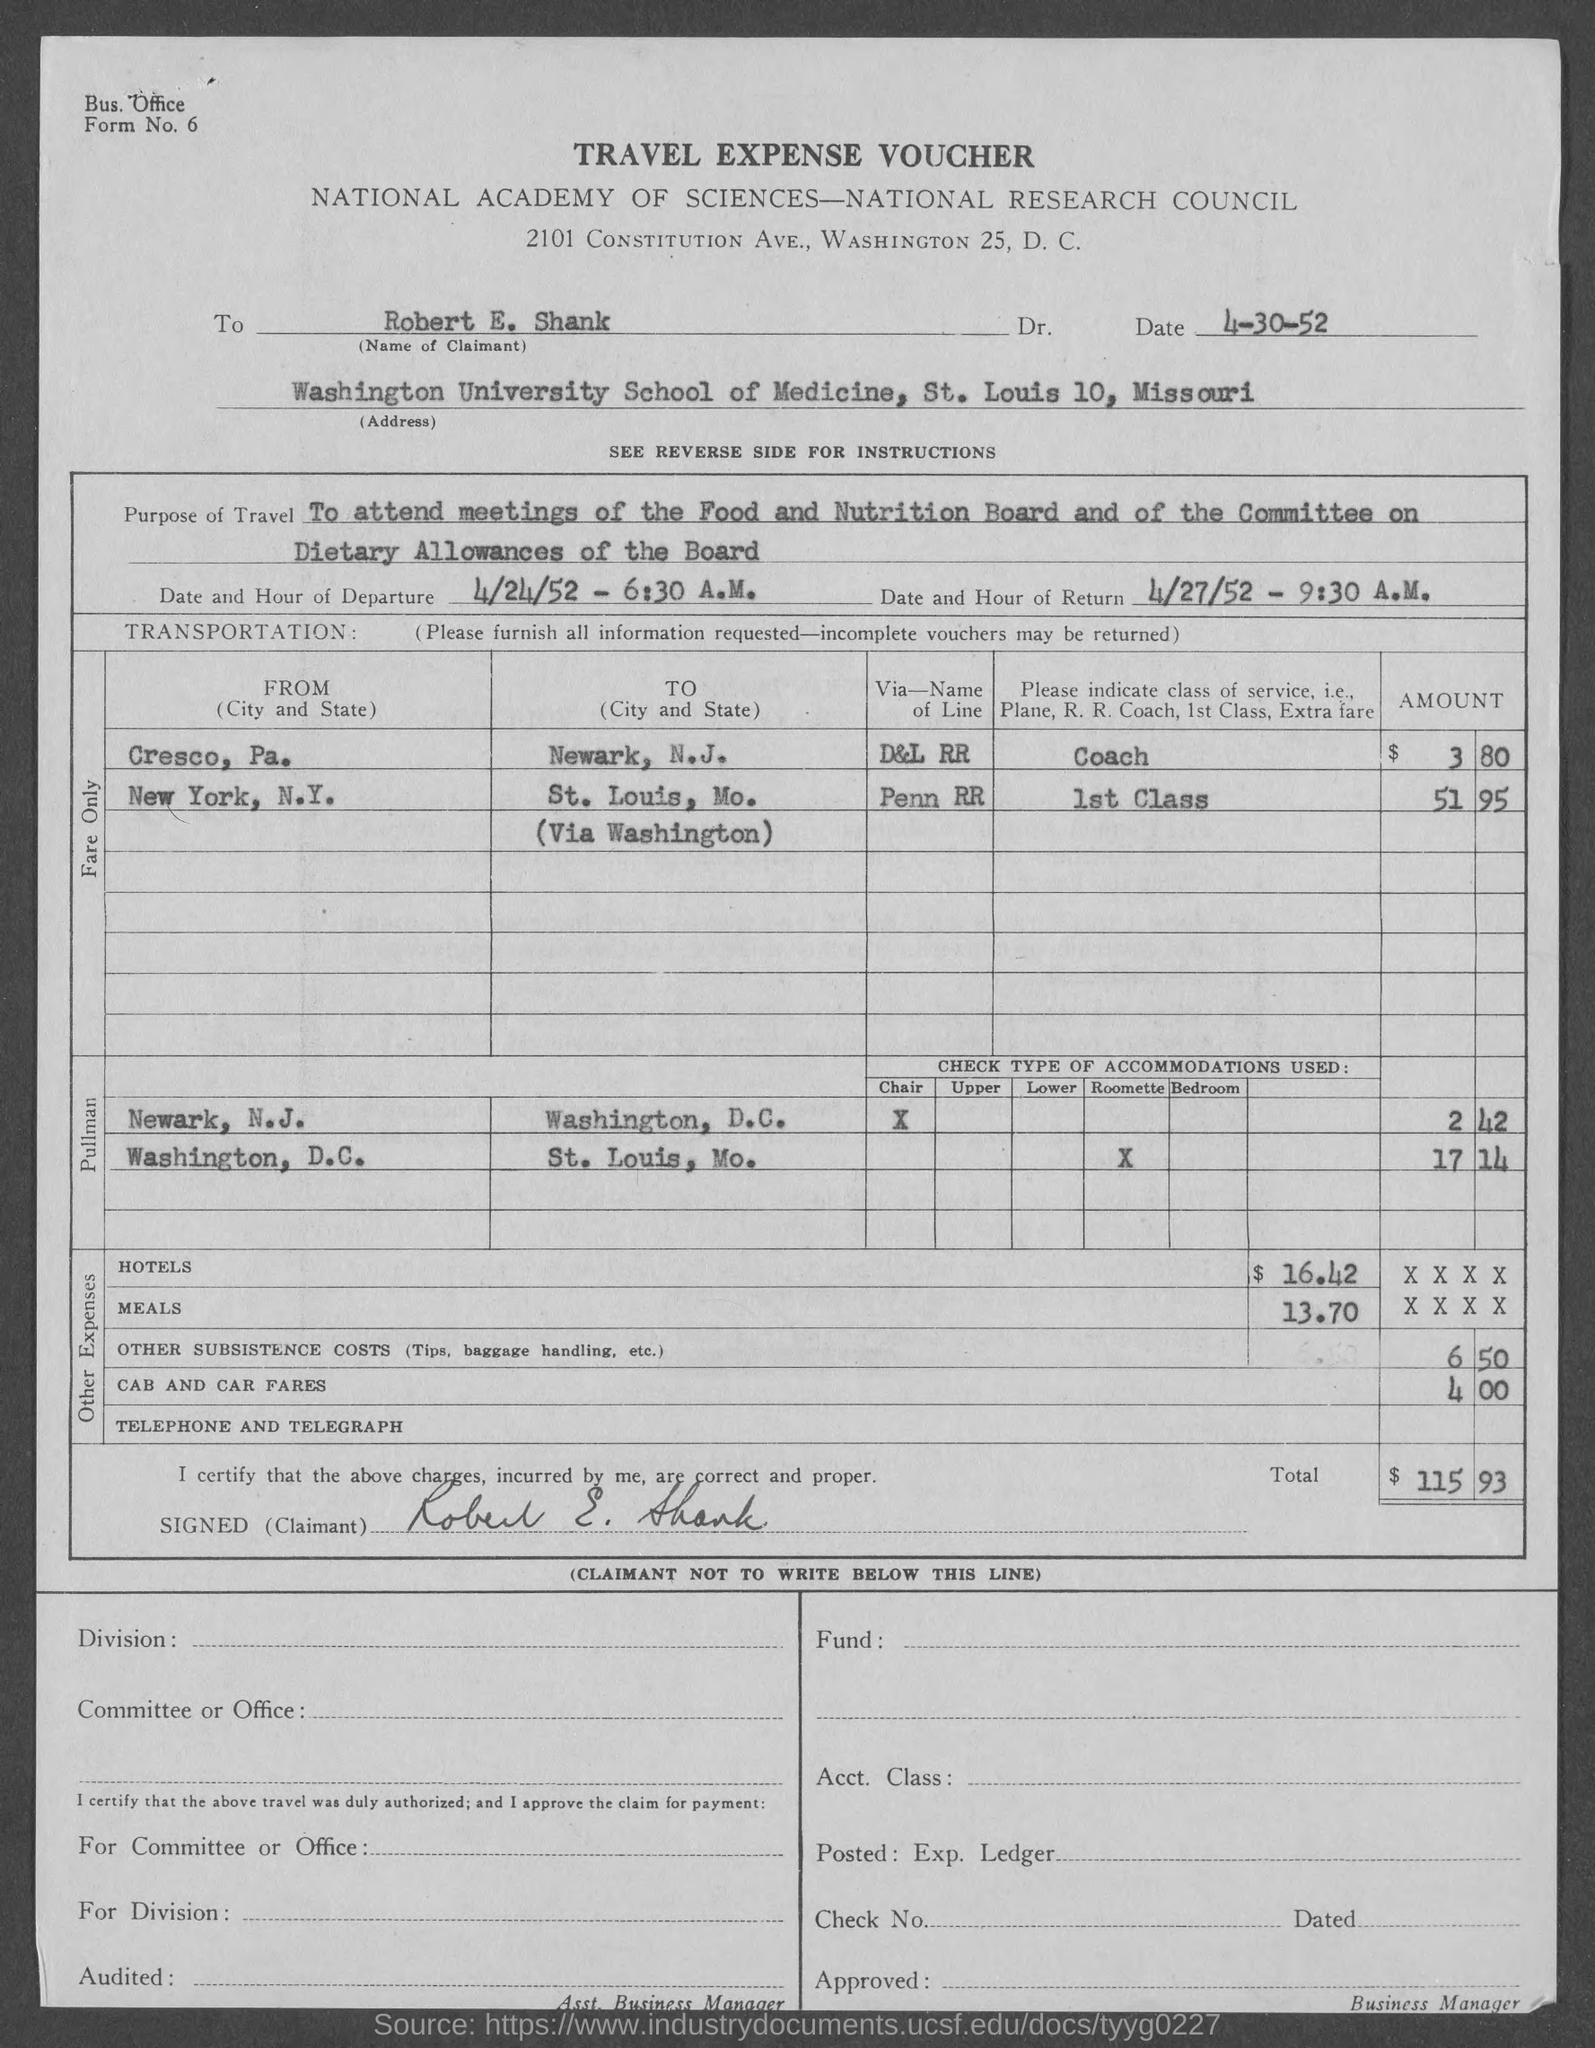What is the name of the university mentioned in the given form ?
Keep it short and to the point. Washington university school of medicine. What is the purpose of travel that is mentioned in the given form ?
Make the answer very short. To attend meetings of the food and nutrition board and of the committee on dietary allowances of the board. What is the date and hour of departure as mentioned in the given page ?
Your response must be concise. 4/24/52 - 6:30 a.m. What is the date and hour of return as mentioned in the given form ?
Give a very brief answer. 4/27/52 - 9:30 a.m. What is the amount for hotels mentioned in the given voucher ?
Your answer should be compact. $ 16.42. What is the amount for meals mentioned in the given meals ?
Make the answer very short. 13.70. 